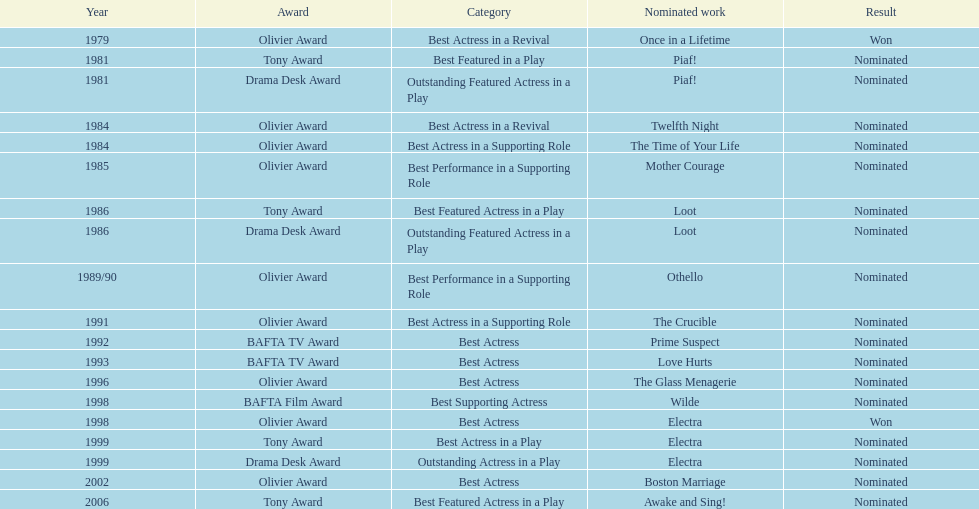Which 1984 play revival brought wanamaker a nomination for best actress? Twelfth Night. 